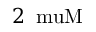<formula> <loc_0><loc_0><loc_500><loc_500>2 \, \ m u M</formula> 